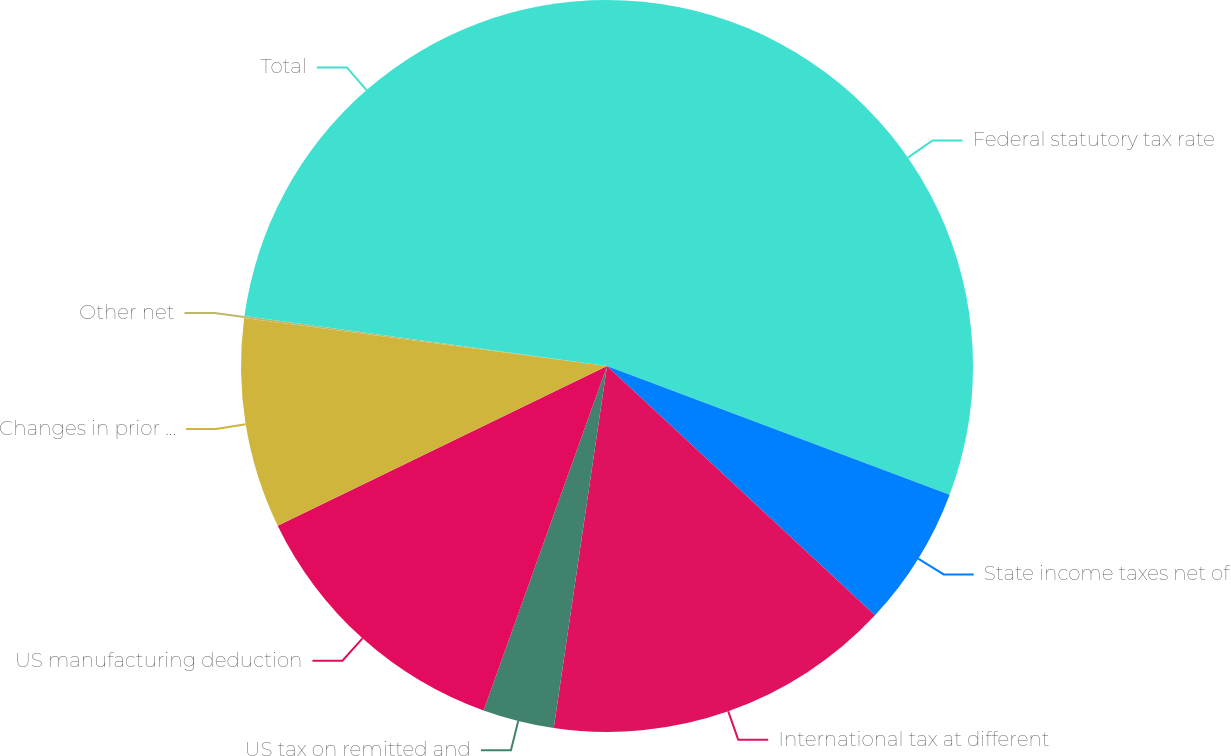Convert chart. <chart><loc_0><loc_0><loc_500><loc_500><pie_chart><fcel>Federal statutory tax rate<fcel>State income taxes net of<fcel>International tax at different<fcel>US tax on remitted and<fcel>US manufacturing deduction<fcel>Changes in prior year tax<fcel>Other net<fcel>Total<nl><fcel>30.72%<fcel>6.21%<fcel>15.4%<fcel>3.15%<fcel>12.34%<fcel>9.28%<fcel>0.09%<fcel>22.82%<nl></chart> 